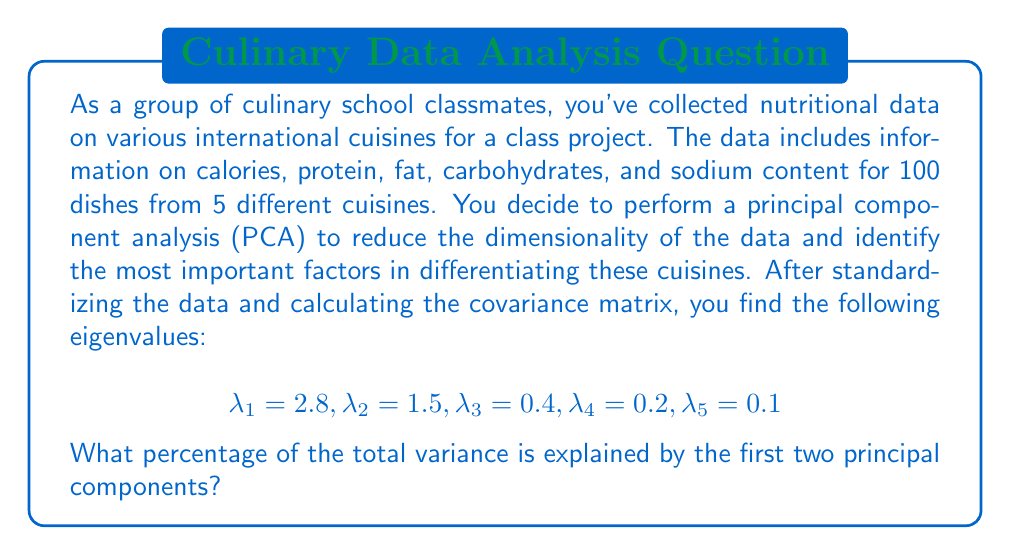Provide a solution to this math problem. To solve this problem, we need to follow these steps:

1. Understand what the eigenvalues represent in PCA:
   Each eigenvalue corresponds to the amount of variance explained by its associated principal component.

2. Calculate the total variance:
   The total variance is the sum of all eigenvalues.
   $$\text{Total Variance} = \sum_{i=1}^5 \lambda_i = 2.8 + 1.5 + 0.4 + 0.2 + 0.1 = 5$$

3. Calculate the variance explained by the first two principal components:
   $$\text{Variance Explained} = \lambda_1 + \lambda_2 = 2.8 + 1.5 = 4.3$$

4. Calculate the percentage of variance explained:
   $$\text{Percentage} = \frac{\text{Variance Explained}}{\text{Total Variance}} \times 100\%$$
   $$= \frac{4.3}{5} \times 100\% = 0.86 \times 100\% = 86\%$$

Therefore, the first two principal components explain 86% of the total variance in the nutritional data of the various cuisines.
Answer: 86% 